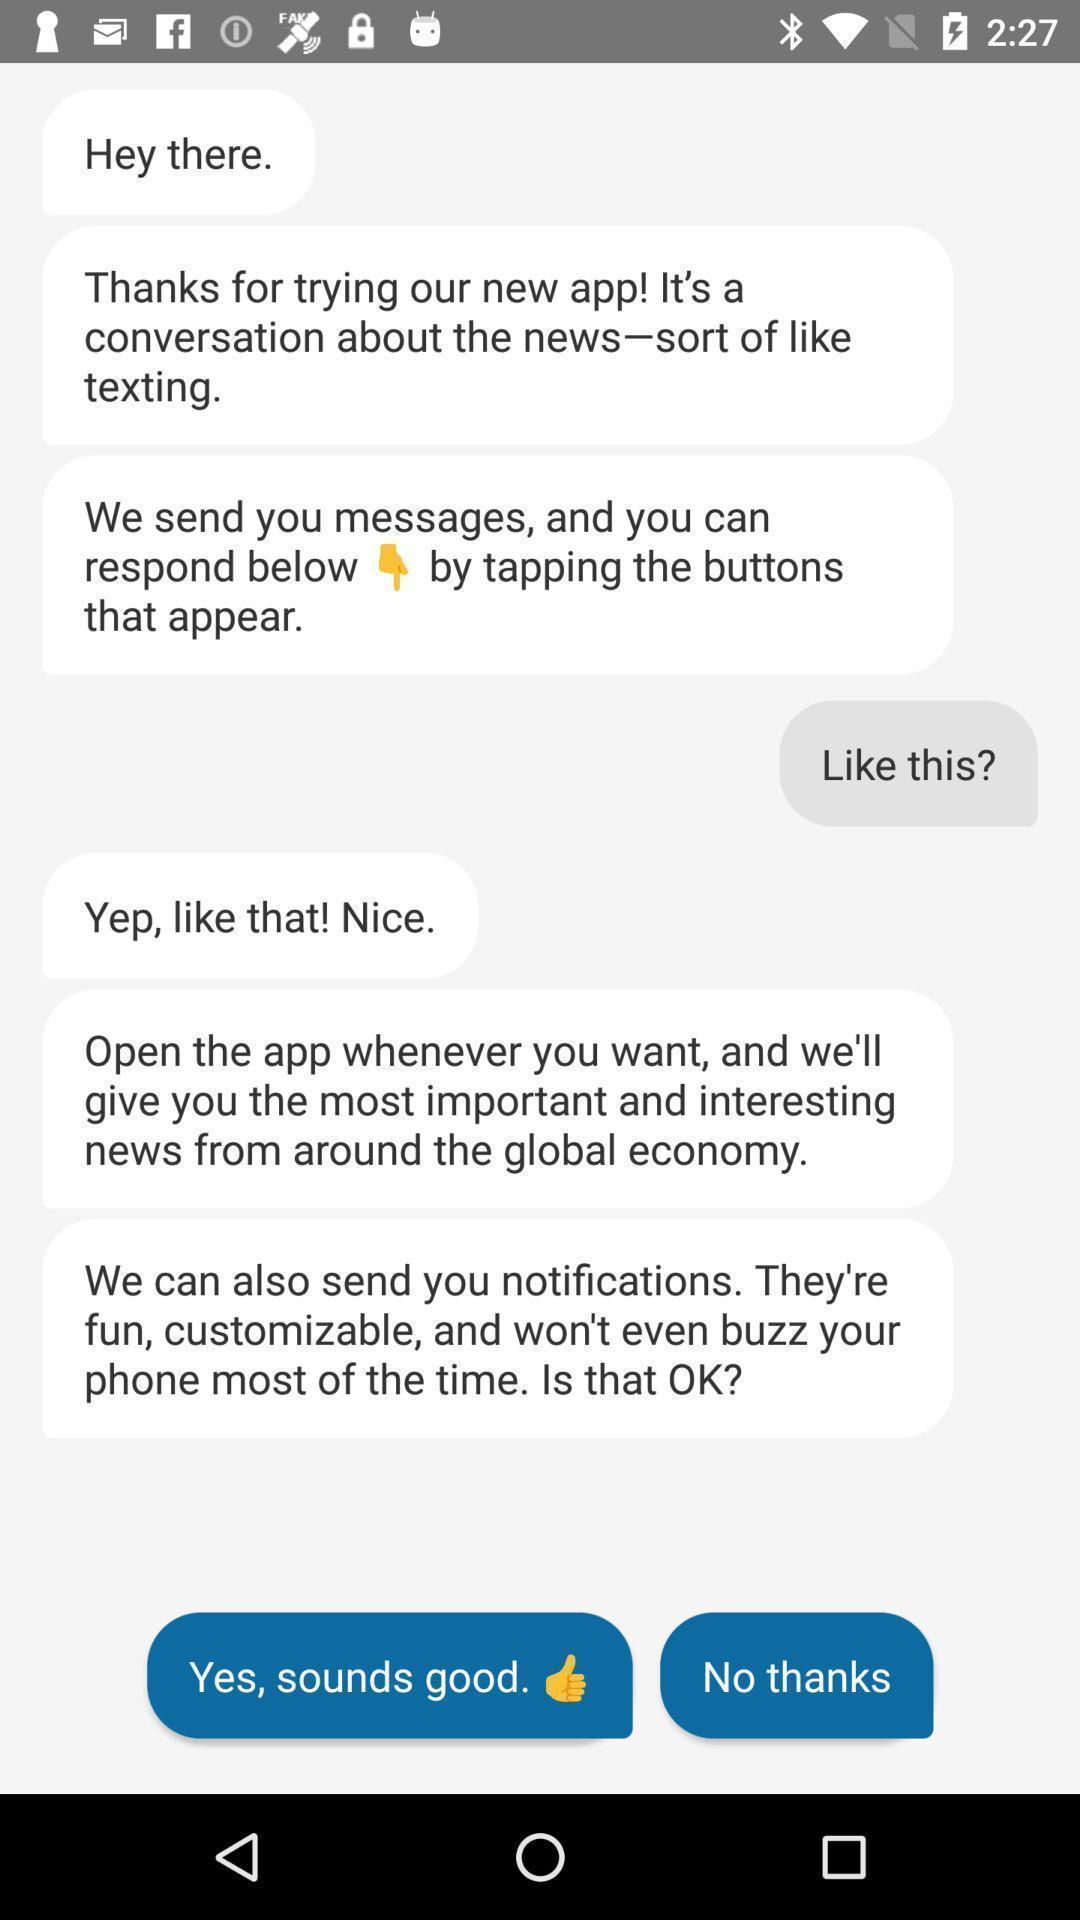Provide a textual representation of this image. Screen page displaying conversation in news app. 